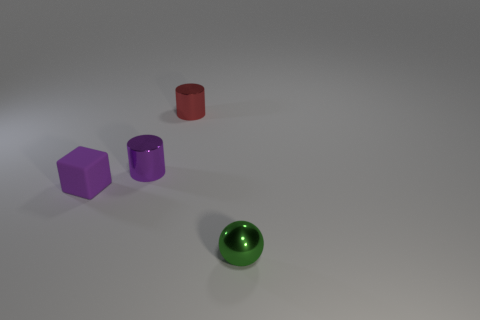Is there any other thing that has the same material as the purple block?
Your answer should be very brief. No. The tiny metal thing in front of the purple object that is behind the purple thing in front of the purple metallic cylinder is what shape?
Provide a succinct answer. Sphere. What number of other things are there of the same shape as the matte object?
Your answer should be compact. 0. The matte cube that is the same size as the metal sphere is what color?
Offer a terse response. Purple. What number of cylinders are either tiny green objects or tiny purple objects?
Give a very brief answer. 1. How many yellow rubber balls are there?
Your answer should be compact. 0. There is a small purple metallic object; is it the same shape as the small shiny thing that is right of the small red object?
Your answer should be very brief. No. The shiny thing that is the same color as the tiny block is what size?
Give a very brief answer. Small. What number of objects are either small brown objects or tiny metallic cylinders?
Make the answer very short. 2. There is a object that is to the left of the shiny object that is left of the red object; what shape is it?
Ensure brevity in your answer.  Cube. 